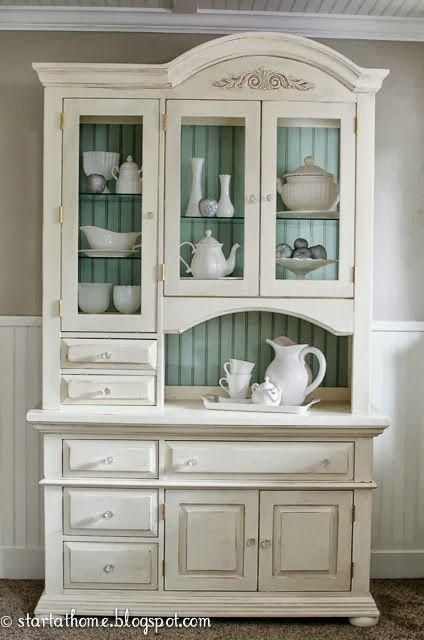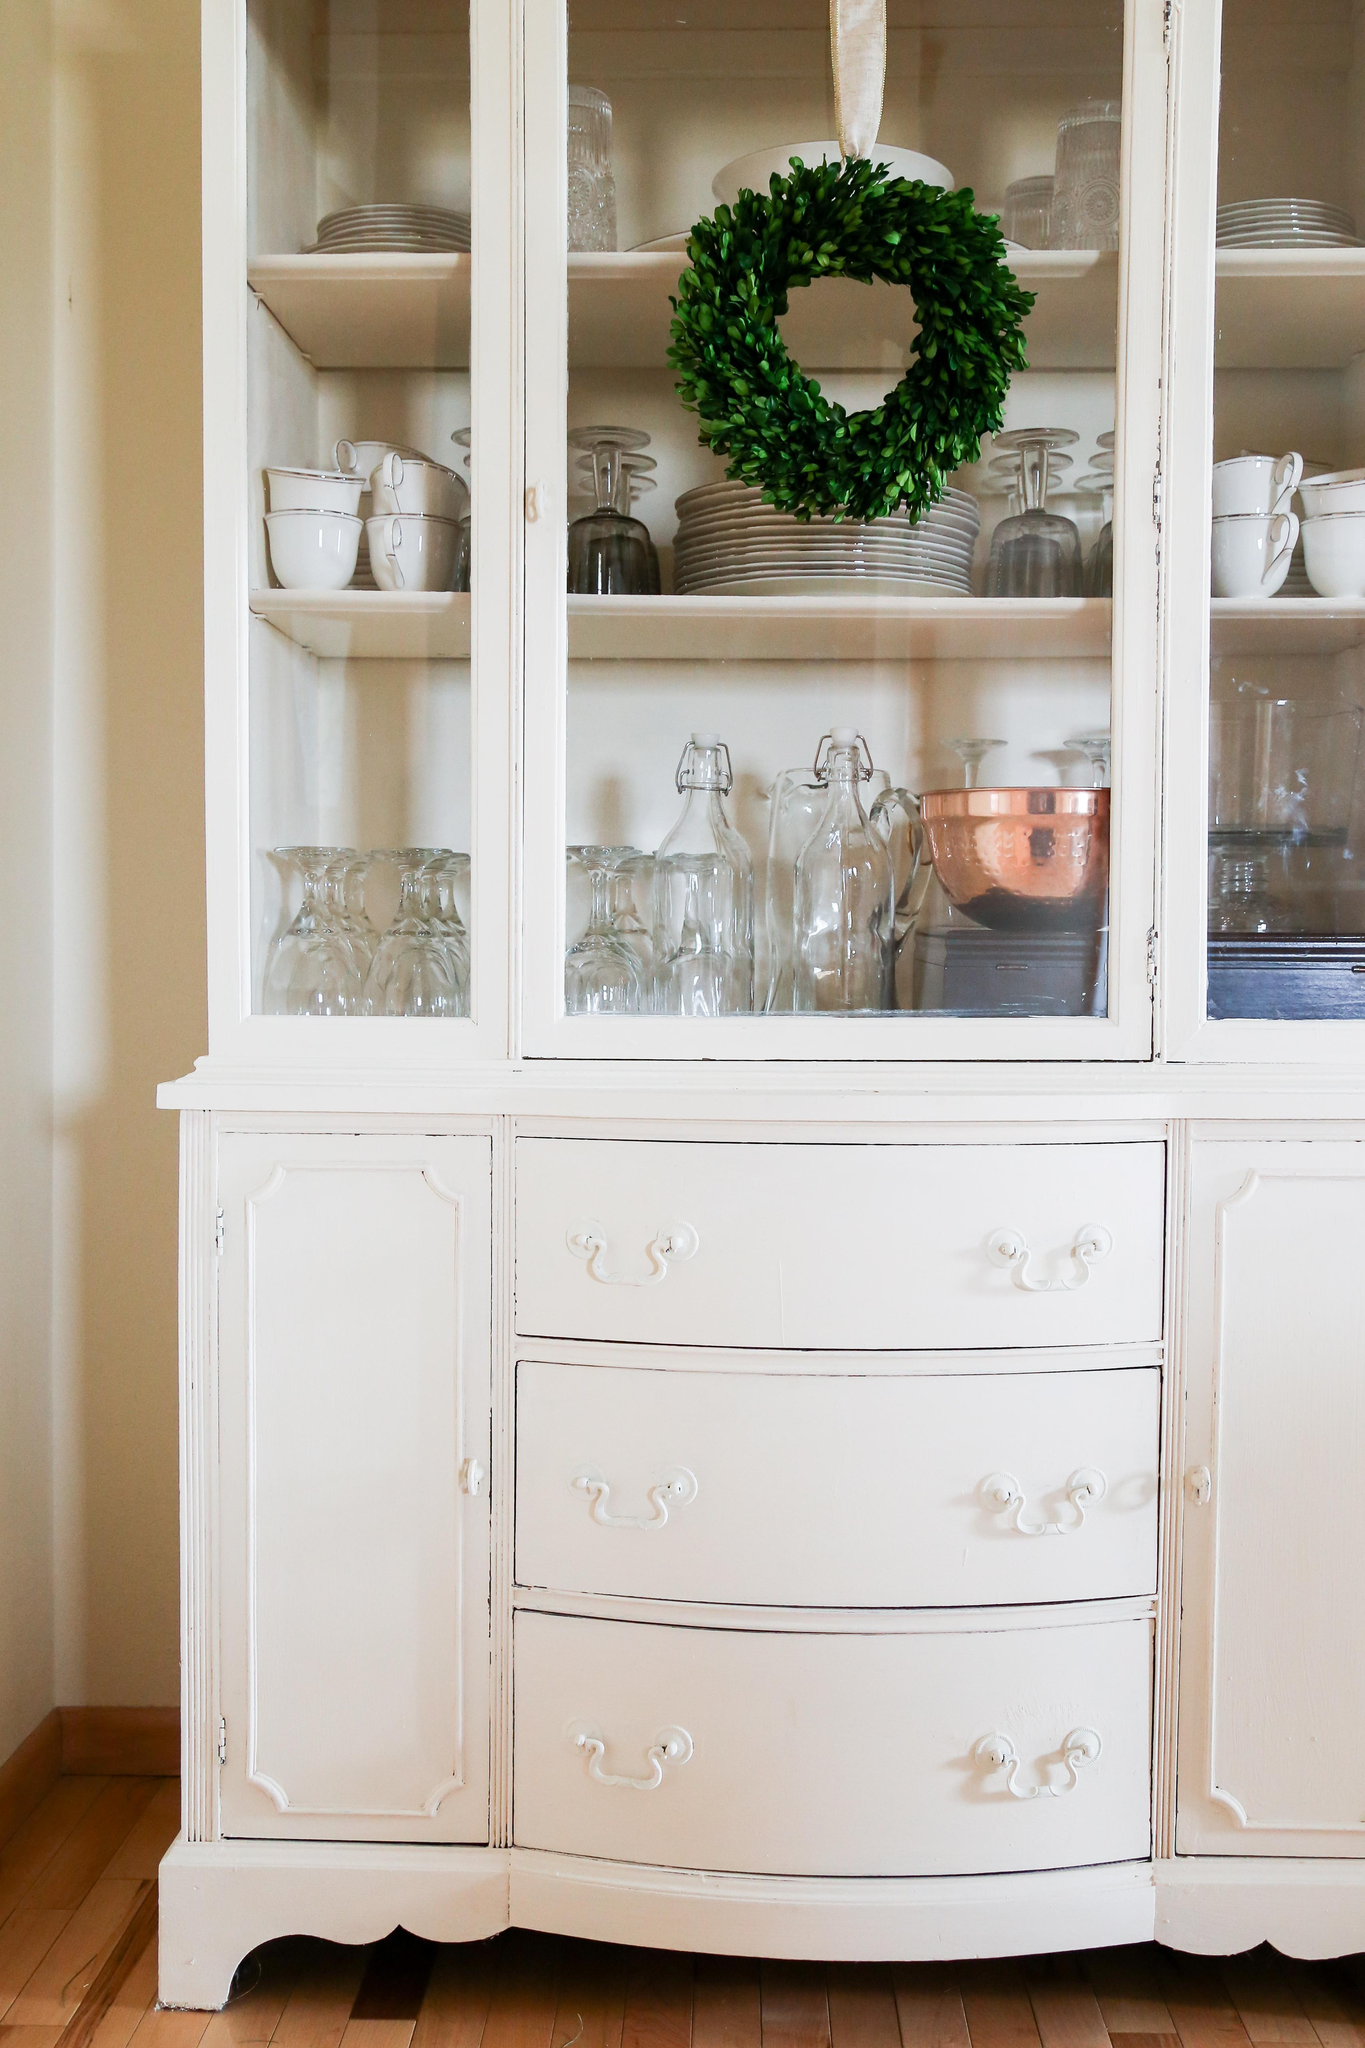The first image is the image on the left, the second image is the image on the right. For the images displayed, is the sentence "At least one cabinet has a non-flat top with nothing perched above it, and a bottom that lacks any scrollwork." factually correct? Answer yes or no. Yes. The first image is the image on the left, the second image is the image on the right. Analyze the images presented: Is the assertion "Within the china cabinet, one of the cabinet's inner walls have been painted green, but not blue." valid? Answer yes or no. Yes. 